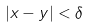<formula> <loc_0><loc_0><loc_500><loc_500>| x - y | < \delta</formula> 